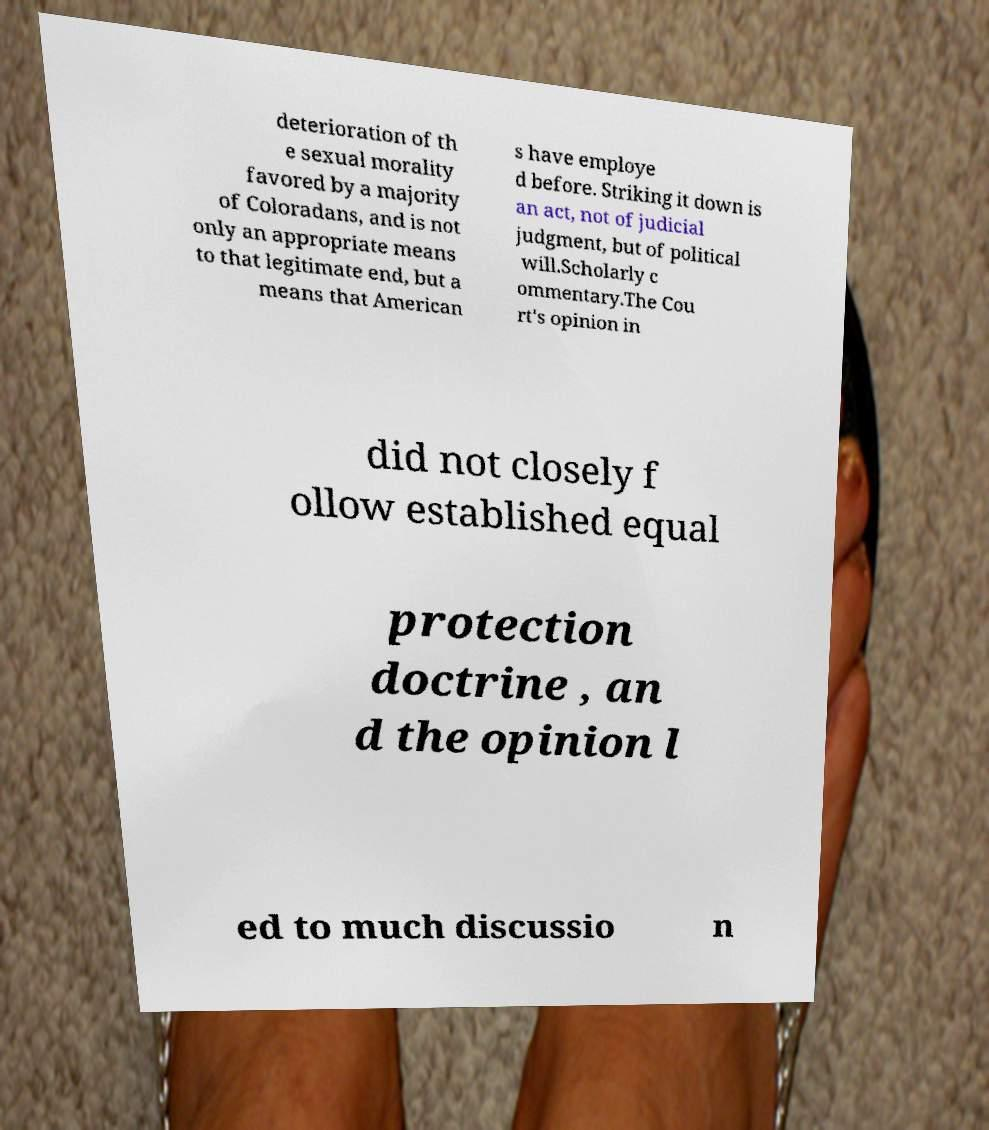Please identify and transcribe the text found in this image. deterioration of th e sexual morality favored by a majority of Coloradans, and is not only an appropriate means to that legitimate end, but a means that American s have employe d before. Striking it down is an act, not of judicial judgment, but of political will.Scholarly c ommentary.The Cou rt's opinion in did not closely f ollow established equal protection doctrine , an d the opinion l ed to much discussio n 